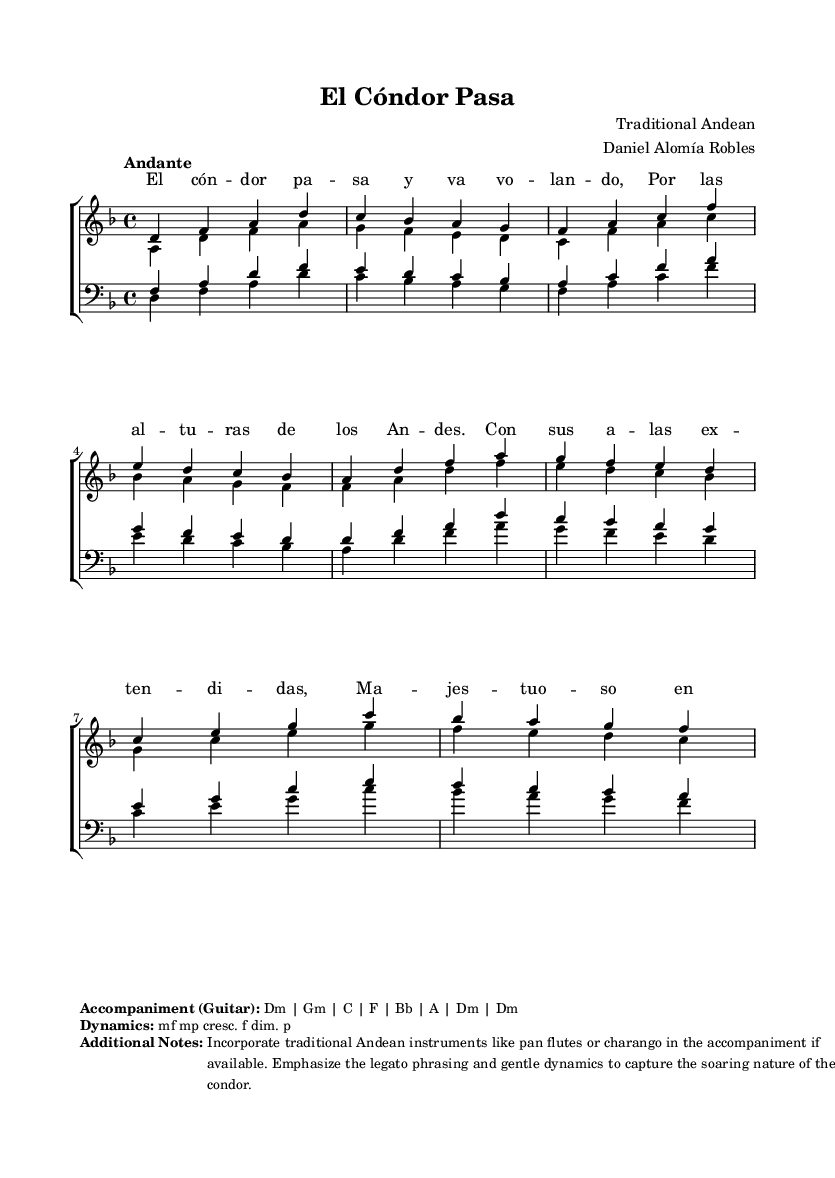What is the key signature of this music? The key signature is D minor, which is indicated by one flat (B flat) at the beginning of the staff.
Answer: D minor What is the time signature of this music? The time signature is 4/4, shown at the beginning of the score, indicating four beats per measure.
Answer: 4/4 What is the tempo marking of this music? The tempo marking is "Andante," which means a moderately slow tempo. This is also directly referenced at the beginning of the score.
Answer: Andante What type of ensemble is this music arranged for? The score is arranged for a mixed choir, as indicated by the presence of separate staffs for sopranos, altos, tenors, and basses.
Answer: Mixed choir What dynamic marking appears in the music? The dynamic markings include mezzo-forte (mf), mezzo-piano (mp), crescendo (cresc.), forte (f), diminuendo (dim.), and piano (p), which indicate the required volume changes throughout the piece.
Answer: mf mp cresc. f dim. p What traditional instruments are suggested for accompaniment? The additional notes mention incorporating traditional Andean instruments like the pan flutes or charango, which can enhance the overall sound of the arrangement.
Answer: Pan flutes, charango How should the phrasing be emphasized in the performance? The instruction emphasizes smooth legato phrasing to capture the soaring nature of the condor, highlighting the importance of gentle dynamics in the expression.
Answer: Legato phrasing 